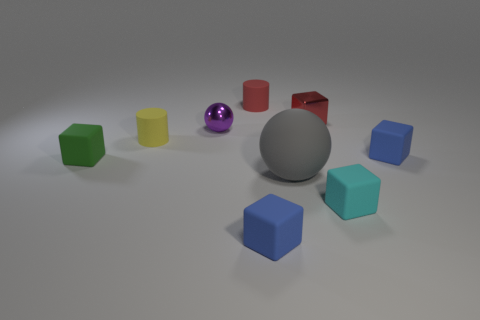Is the yellow cylinder the same size as the cyan rubber cube?
Give a very brief answer. Yes. What is the material of the small red thing to the right of the tiny red rubber cylinder behind the red shiny thing?
Offer a very short reply. Metal. How big is the sphere in front of the small shiny thing that is to the left of the red rubber object?
Keep it short and to the point. Large. Are there more tiny blue cubes that are behind the small purple thing than yellow matte cylinders to the right of the gray sphere?
Provide a short and direct response. No. How many cylinders are either tiny blue rubber objects or small yellow objects?
Your answer should be very brief. 1. Is there any other thing that is the same size as the gray rubber sphere?
Your answer should be compact. No. Do the object left of the small yellow rubber object and the tiny cyan matte object have the same shape?
Offer a terse response. Yes. What color is the small ball?
Give a very brief answer. Purple. There is another metallic object that is the same shape as the small green thing; what color is it?
Your response must be concise. Red. What number of other gray objects are the same shape as the big object?
Keep it short and to the point. 0. 